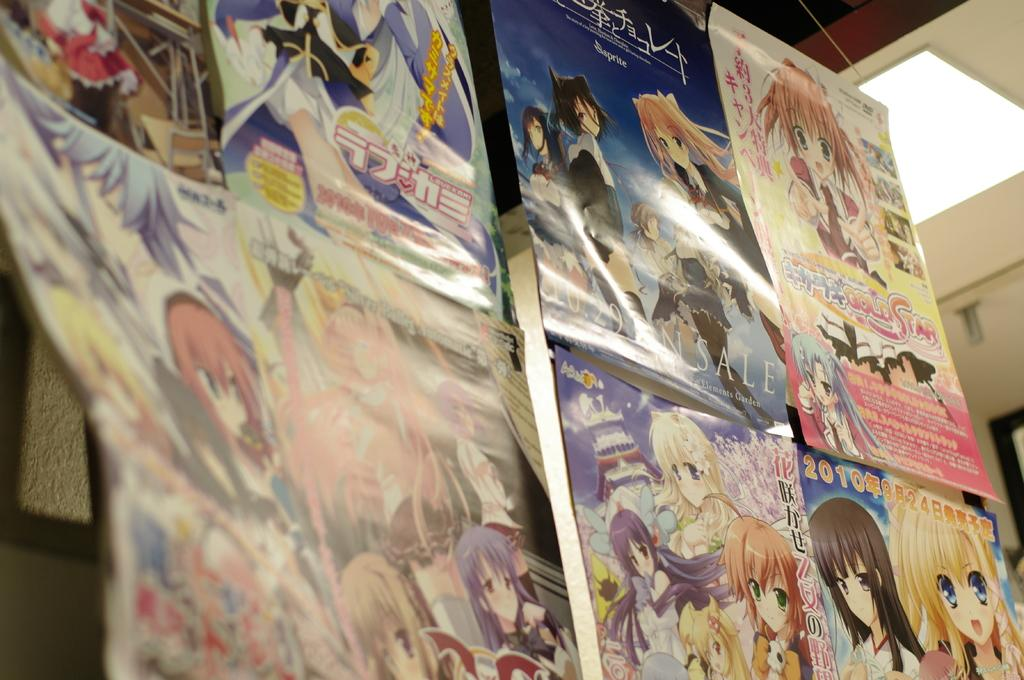<image>
Provide a brief description of the given image. several chinese comics books are display with one being released in 2010 